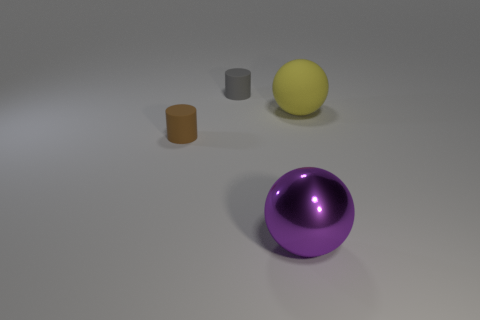How many brown cylinders are made of the same material as the big purple thing?
Your answer should be compact. 0. Is the number of rubber balls left of the brown matte cylinder greater than the number of tiny brown matte cylinders?
Provide a short and direct response. No. Are there any brown matte objects that have the same shape as the gray rubber object?
Your answer should be very brief. Yes. How many things are large green rubber cylinders or tiny cylinders?
Your answer should be compact. 2. There is a tiny rubber cylinder behind the rubber object that is right of the large metallic thing; what number of small brown cylinders are to the left of it?
Offer a terse response. 1. What material is the purple object that is the same shape as the big yellow object?
Your response must be concise. Metal. There is a object that is both in front of the yellow object and behind the big purple metallic thing; what is its material?
Your answer should be compact. Rubber. Is the number of tiny gray matte objects that are to the right of the large yellow rubber sphere less than the number of big rubber things to the left of the purple object?
Offer a terse response. No. How many other objects are the same size as the gray thing?
Your answer should be compact. 1. The big thing that is behind the small thing that is in front of the big sphere that is right of the large shiny object is what shape?
Provide a succinct answer. Sphere. 